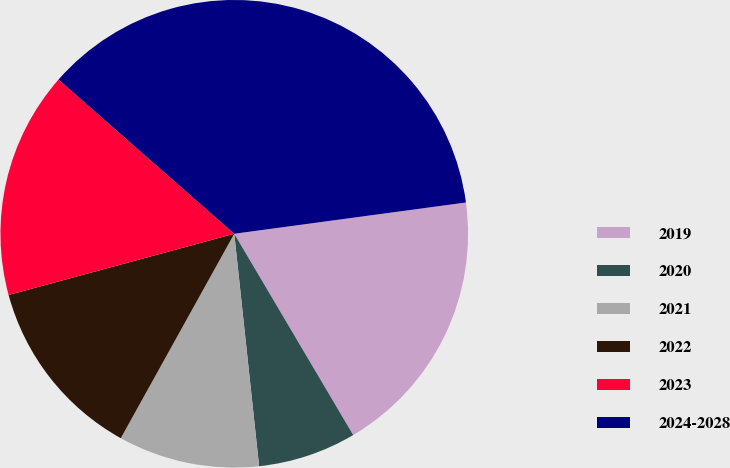<chart> <loc_0><loc_0><loc_500><loc_500><pie_chart><fcel>2019<fcel>2020<fcel>2021<fcel>2022<fcel>2023<fcel>2024-2028<nl><fcel>18.64%<fcel>6.8%<fcel>9.76%<fcel>12.72%<fcel>15.68%<fcel>36.4%<nl></chart> 